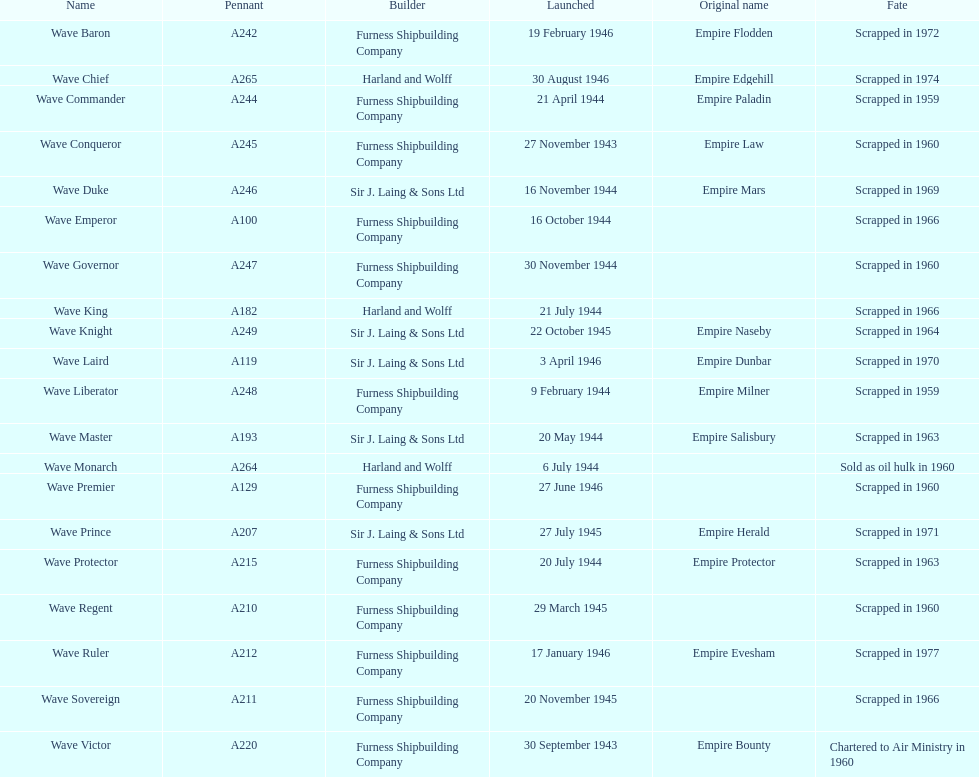When was the first vessel launched? 30 September 1943. 